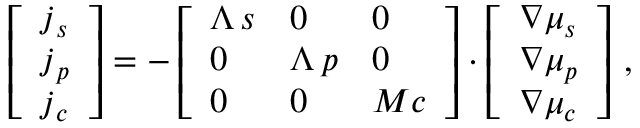Convert formula to latex. <formula><loc_0><loc_0><loc_500><loc_500>\left [ \begin{array} { l } { j _ { s } } \\ { j _ { p } } \\ { j _ { c } } \end{array} \right ] = - \left [ \begin{array} { l l l } { \Lambda \, s } & { 0 } & { 0 } \\ { 0 } & { \Lambda \, p } & { 0 } \\ { 0 } & { 0 } & { M c } \end{array} \right ] \cdot \left [ \begin{array} { l } { \boldsymbol \nabla \mu _ { s } } \\ { \boldsymbol \nabla \mu _ { p } } \\ { \boldsymbol \nabla \mu _ { c } } \end{array} \right ] \, ,</formula> 